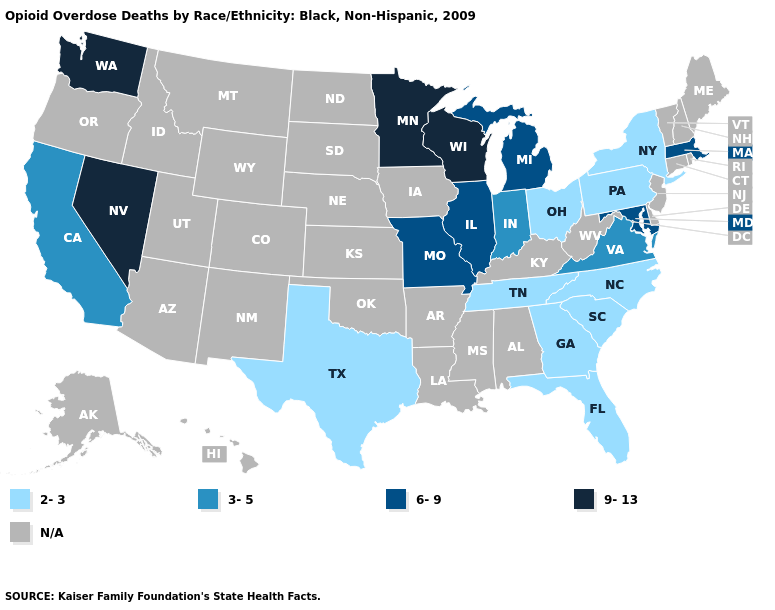Among the states that border South Dakota , which have the lowest value?
Be succinct. Minnesota. Name the states that have a value in the range 9-13?
Keep it brief. Minnesota, Nevada, Washington, Wisconsin. What is the value of Arkansas?
Concise answer only. N/A. What is the lowest value in the South?
Keep it brief. 2-3. Among the states that border Michigan , which have the highest value?
Short answer required. Wisconsin. Name the states that have a value in the range 6-9?
Short answer required. Illinois, Maryland, Massachusetts, Michigan, Missouri. Does Maryland have the highest value in the South?
Keep it brief. Yes. What is the value of Kentucky?
Quick response, please. N/A. Name the states that have a value in the range 3-5?
Concise answer only. California, Indiana, Virginia. Name the states that have a value in the range 9-13?
Keep it brief. Minnesota, Nevada, Washington, Wisconsin. What is the value of Arizona?
Keep it brief. N/A. What is the value of Oklahoma?
Quick response, please. N/A. Which states have the highest value in the USA?
Concise answer only. Minnesota, Nevada, Washington, Wisconsin. 